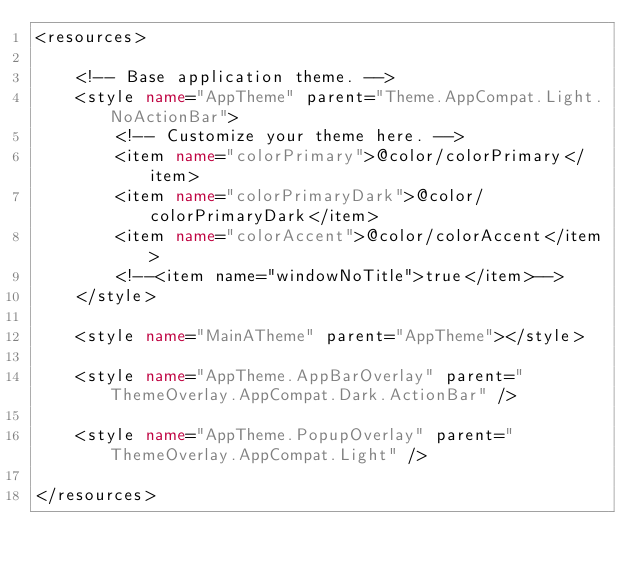Convert code to text. <code><loc_0><loc_0><loc_500><loc_500><_XML_><resources>

    <!-- Base application theme. -->
    <style name="AppTheme" parent="Theme.AppCompat.Light.NoActionBar">
        <!-- Customize your theme here. -->
        <item name="colorPrimary">@color/colorPrimary</item>
        <item name="colorPrimaryDark">@color/colorPrimaryDark</item>
        <item name="colorAccent">@color/colorAccent</item>
        <!--<item name="windowNoTitle">true</item>-->
    </style>

    <style name="MainATheme" parent="AppTheme"></style>

    <style name="AppTheme.AppBarOverlay" parent="ThemeOverlay.AppCompat.Dark.ActionBar" />

    <style name="AppTheme.PopupOverlay" parent="ThemeOverlay.AppCompat.Light" />

</resources>
</code> 